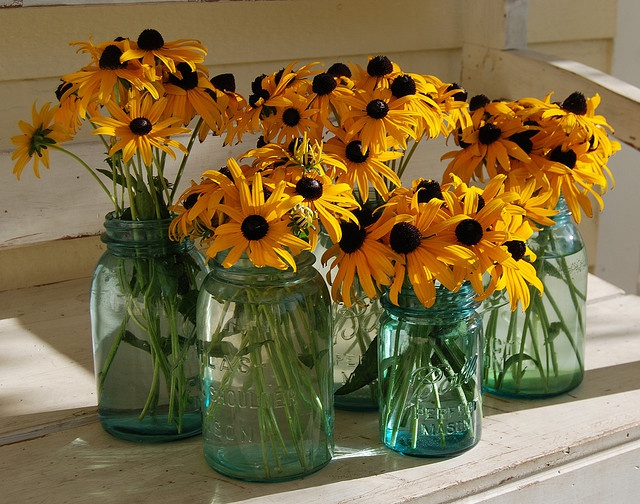Describe the objects in this image and their specific colors. I can see vase in gray and darkgreen tones, vase in gray, black, and darkgreen tones, vase in gray, darkgreen, black, and teal tones, vase in gray, darkgray, and darkgreen tones, and vase in gray, black, olive, darkgreen, and tan tones in this image. 